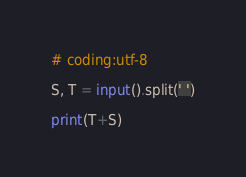<code> <loc_0><loc_0><loc_500><loc_500><_Python_># coding:utf-8

S, T = input().split(' ')

print(T+S)</code> 